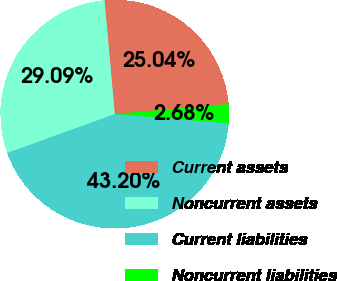Convert chart. <chart><loc_0><loc_0><loc_500><loc_500><pie_chart><fcel>Current assets<fcel>Noncurrent assets<fcel>Current liabilities<fcel>Noncurrent liabilities<nl><fcel>25.04%<fcel>29.09%<fcel>43.2%<fcel>2.68%<nl></chart> 